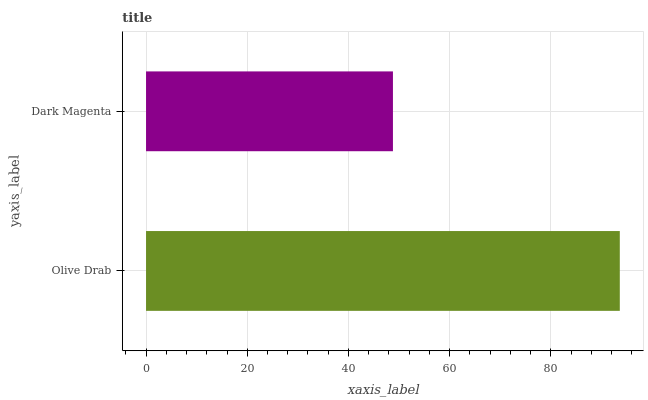Is Dark Magenta the minimum?
Answer yes or no. Yes. Is Olive Drab the maximum?
Answer yes or no. Yes. Is Dark Magenta the maximum?
Answer yes or no. No. Is Olive Drab greater than Dark Magenta?
Answer yes or no. Yes. Is Dark Magenta less than Olive Drab?
Answer yes or no. Yes. Is Dark Magenta greater than Olive Drab?
Answer yes or no. No. Is Olive Drab less than Dark Magenta?
Answer yes or no. No. Is Olive Drab the high median?
Answer yes or no. Yes. Is Dark Magenta the low median?
Answer yes or no. Yes. Is Dark Magenta the high median?
Answer yes or no. No. Is Olive Drab the low median?
Answer yes or no. No. 